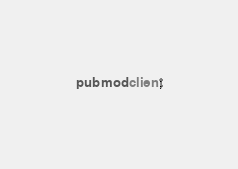<code> <loc_0><loc_0><loc_500><loc_500><_Rust_>pub mod client;</code> 